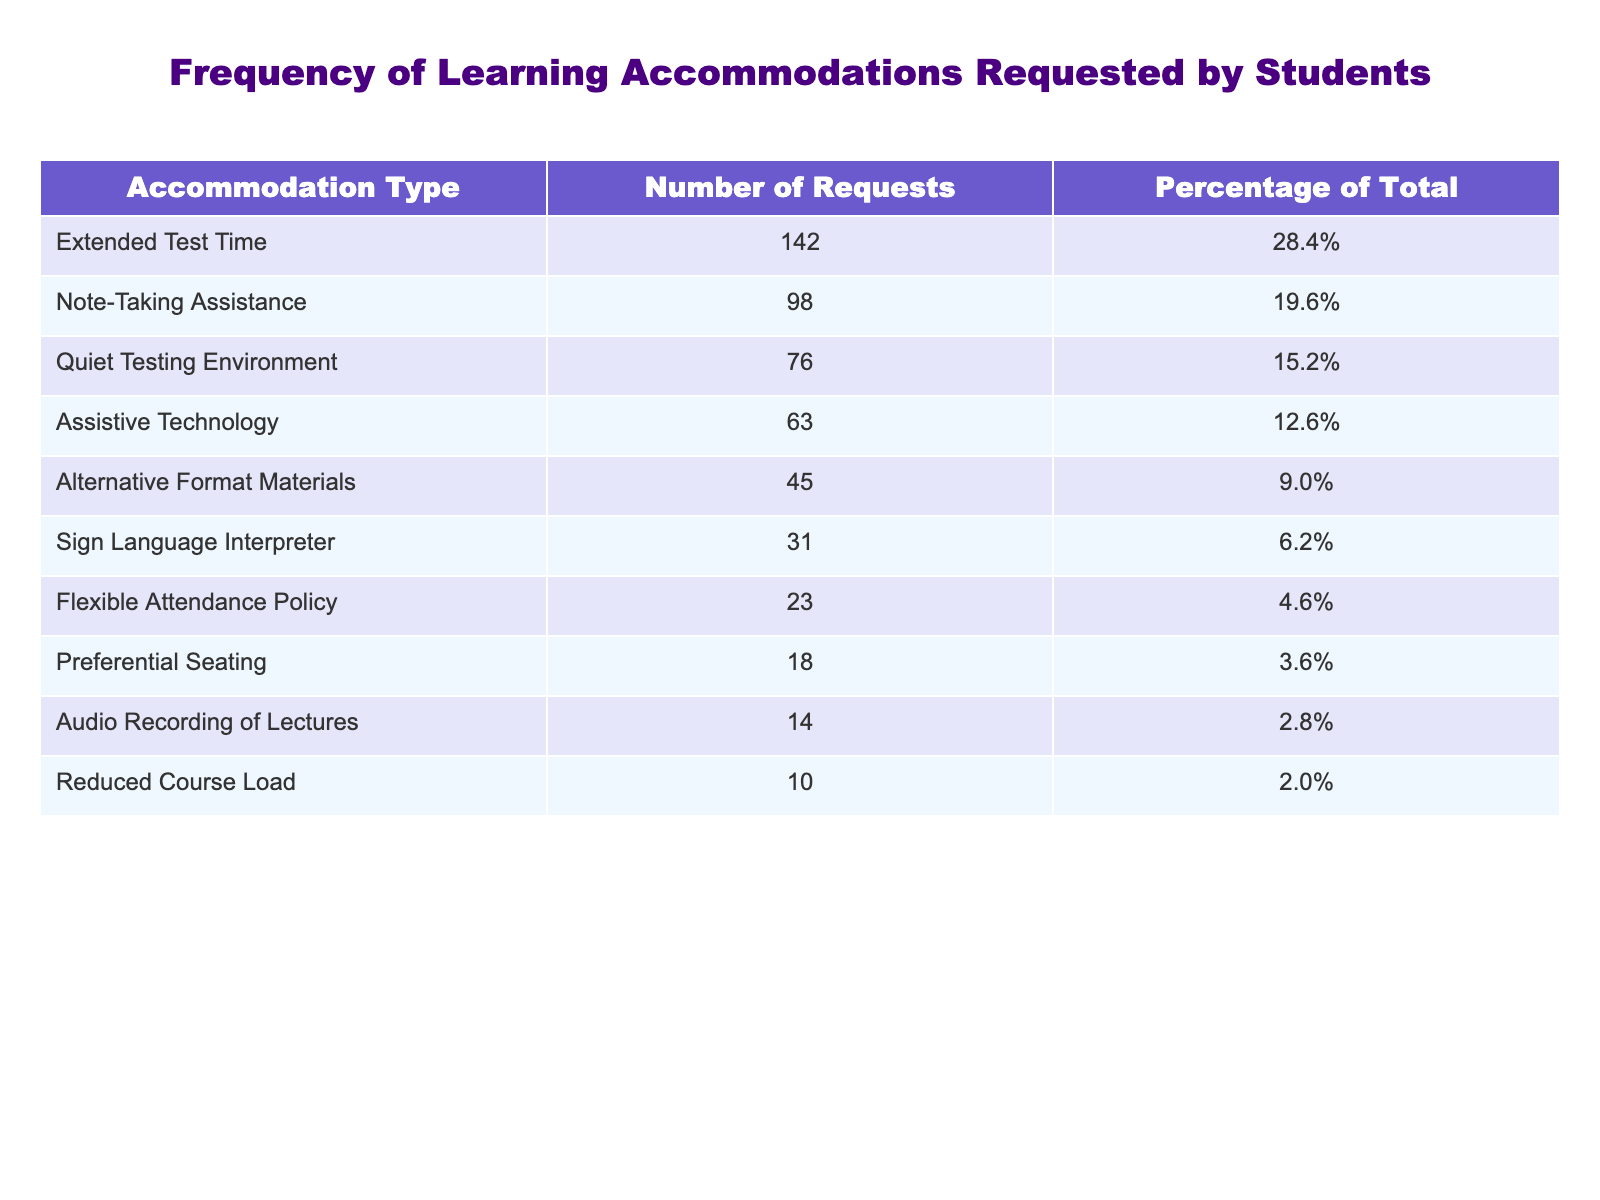What is the most requested accommodation type? The table shows the number of requests for different accommodation types. The one with the highest number is "Extended Test Time," which received 142 requests.
Answer: Extended Test Time How many requests were made for Note-Taking Assistance? According to the table, the number of requests for Note-Taking Assistance is listed as 98.
Answer: 98 What percentage of total requests were for Assistive Technology? The table presents the Percentage of Total for Assistive Technology, which is 12.6%.
Answer: 12.6% What is the total number of requests for all accommodation types? To find the total, sum the Number of Requests: 142 + 98 + 76 + 63 + 45 + 31 + 23 + 18 + 14 + 10 =  514.
Answer: 514 Which accommodation type has the lowest number of requests, and what is that number? The lowest number of requests is for "Reduced Course Load," with just 10 requests.
Answer: Reduced Course Load, 10 Is the percentage of requests for Flexible Attendance Policy greater than 5%? The table shows that Flexible Attendance Policy has a percentage of 4.6%, which is less than 5%.
Answer: No What is the difference in the number of requests between the highest and lowest accommodation types? The highest is 142 (Extended Test Time) and the lowest is 10 (Reduced Course Load). The difference is 142 - 10 = 132.
Answer: 132 How many accommodation types had requests of less than 50? The accommodations with requests less than 50 are "Alternative Format Materials" (45), "Sign Language Interpreter" (31), "Flexible Attendance Policy" (23), "Preferential Seating" (18), "Audio Recording of Lectures" (14), and "Reduced Course Load" (10). This totals 6 accommodation types.
Answer: 6 Calculate the average number of requests for all accommodation types. The average is calculated by dividing the total number of requests (514) by the number of accommodation types (10): 514 / 10 = 51.4.
Answer: 51.4 Which accommodation type accounts for more than 20% of total requests? The percentages for accommodations are: Extended Test Time (28.4%) and Note-Taking Assistance (19.6%). Only Extended Test Time exceeds 20%.
Answer: Extended Test Time 